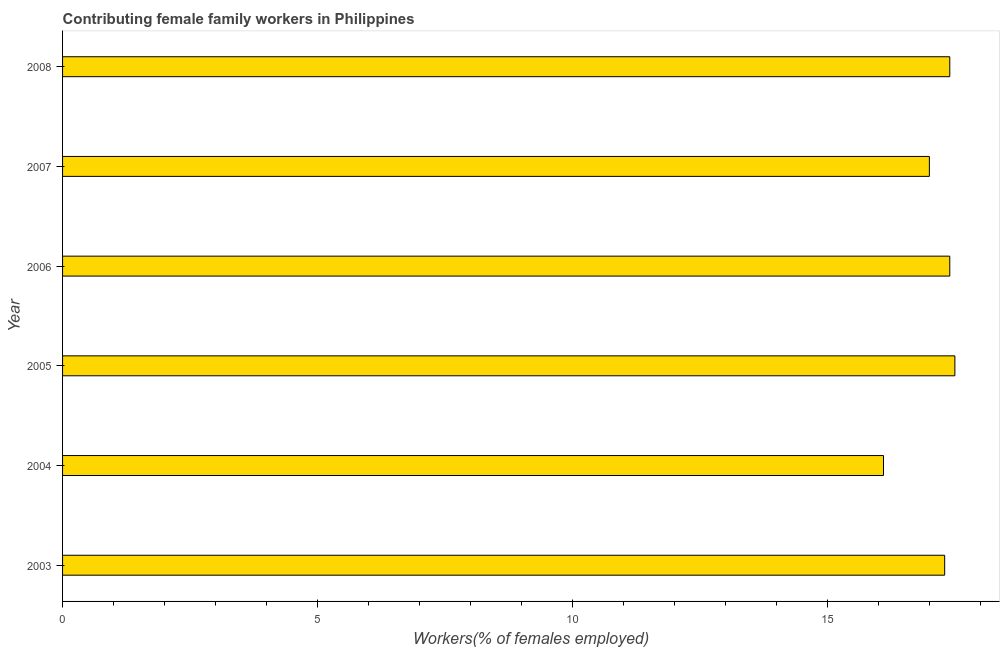What is the title of the graph?
Give a very brief answer. Contributing female family workers in Philippines. What is the label or title of the X-axis?
Offer a very short reply. Workers(% of females employed). What is the label or title of the Y-axis?
Ensure brevity in your answer.  Year. What is the contributing female family workers in 2007?
Make the answer very short. 17. Across all years, what is the maximum contributing female family workers?
Provide a succinct answer. 17.5. Across all years, what is the minimum contributing female family workers?
Offer a very short reply. 16.1. In which year was the contributing female family workers maximum?
Offer a very short reply. 2005. What is the sum of the contributing female family workers?
Your response must be concise. 102.7. What is the difference between the contributing female family workers in 2005 and 2006?
Offer a terse response. 0.1. What is the average contributing female family workers per year?
Your response must be concise. 17.12. What is the median contributing female family workers?
Ensure brevity in your answer.  17.35. What is the ratio of the contributing female family workers in 2005 to that in 2008?
Provide a succinct answer. 1.01. Is the difference between the contributing female family workers in 2003 and 2006 greater than the difference between any two years?
Offer a terse response. No. In how many years, is the contributing female family workers greater than the average contributing female family workers taken over all years?
Make the answer very short. 4. How many bars are there?
Give a very brief answer. 6. Are all the bars in the graph horizontal?
Offer a terse response. Yes. How many years are there in the graph?
Offer a very short reply. 6. What is the difference between two consecutive major ticks on the X-axis?
Make the answer very short. 5. Are the values on the major ticks of X-axis written in scientific E-notation?
Ensure brevity in your answer.  No. What is the Workers(% of females employed) in 2003?
Keep it short and to the point. 17.3. What is the Workers(% of females employed) of 2004?
Ensure brevity in your answer.  16.1. What is the Workers(% of females employed) in 2005?
Your response must be concise. 17.5. What is the Workers(% of females employed) in 2006?
Your response must be concise. 17.4. What is the Workers(% of females employed) of 2008?
Your answer should be compact. 17.4. What is the difference between the Workers(% of females employed) in 2003 and 2004?
Offer a very short reply. 1.2. What is the difference between the Workers(% of females employed) in 2003 and 2007?
Ensure brevity in your answer.  0.3. What is the difference between the Workers(% of females employed) in 2004 and 2005?
Provide a succinct answer. -1.4. What is the difference between the Workers(% of females employed) in 2004 and 2007?
Give a very brief answer. -0.9. What is the difference between the Workers(% of females employed) in 2005 and 2007?
Give a very brief answer. 0.5. What is the difference between the Workers(% of females employed) in 2005 and 2008?
Make the answer very short. 0.1. What is the difference between the Workers(% of females employed) in 2007 and 2008?
Provide a short and direct response. -0.4. What is the ratio of the Workers(% of females employed) in 2003 to that in 2004?
Offer a very short reply. 1.07. What is the ratio of the Workers(% of females employed) in 2003 to that in 2008?
Provide a succinct answer. 0.99. What is the ratio of the Workers(% of females employed) in 2004 to that in 2006?
Your answer should be very brief. 0.93. What is the ratio of the Workers(% of females employed) in 2004 to that in 2007?
Ensure brevity in your answer.  0.95. What is the ratio of the Workers(% of females employed) in 2004 to that in 2008?
Make the answer very short. 0.93. What is the ratio of the Workers(% of females employed) in 2005 to that in 2007?
Your answer should be compact. 1.03. What is the ratio of the Workers(% of females employed) in 2006 to that in 2007?
Your answer should be very brief. 1.02. 